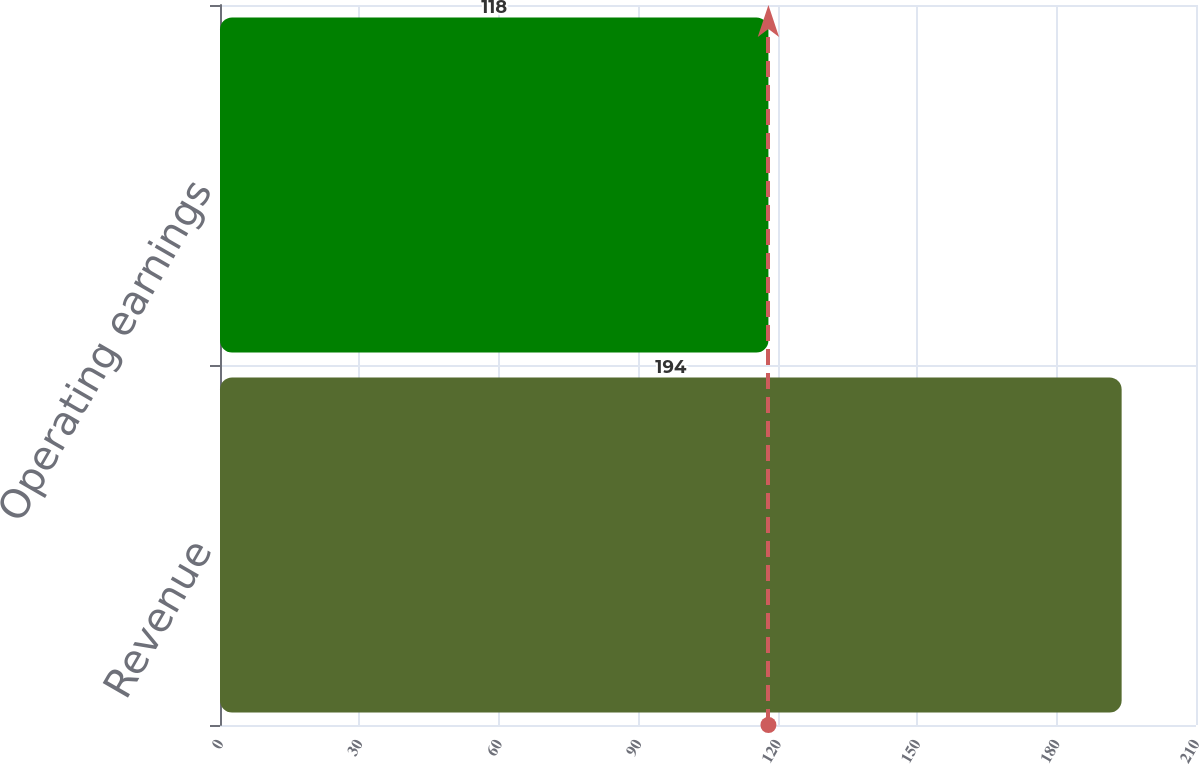<chart> <loc_0><loc_0><loc_500><loc_500><bar_chart><fcel>Revenue<fcel>Operating earnings<nl><fcel>194<fcel>118<nl></chart> 